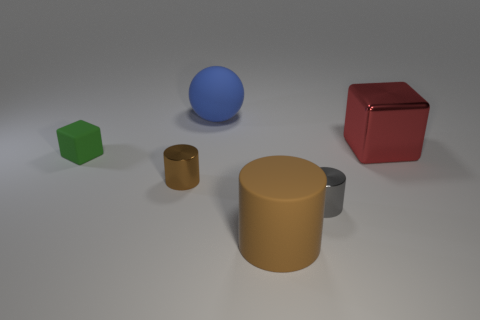Add 3 large blue balls. How many objects exist? 9 Subtract all cubes. How many objects are left? 4 Subtract 0 blue cylinders. How many objects are left? 6 Subtract all large yellow matte spheres. Subtract all big shiny cubes. How many objects are left? 5 Add 1 blue balls. How many blue balls are left? 2 Add 3 large shiny cubes. How many large shiny cubes exist? 4 